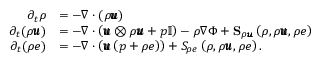<formula> <loc_0><loc_0><loc_500><loc_500>\begin{array} { r l } { \partial _ { t } \rho } & { = - \nabla \cdot \left ( \rho \pm b { u } \right ) } \\ { \partial _ { t } ( \rho \pm b { u } ) } & { = - \nabla \cdot \left ( \pm b { u } \otimes \rho \pm b { u } + p \mathbb { I } \right ) - \rho \nabla \Phi + S _ { \rho \pm b { u } } \left ( \rho , \rho \pm b { u } , \rho e \right ) } \\ { \partial _ { t } ( \rho e ) } & { = - \nabla \cdot \left ( \pm b { u } \left ( p + \rho e \right ) \right ) + S _ { \rho e } \left ( \rho , \rho \pm b { u } , \rho e \right ) . } \end{array}</formula> 